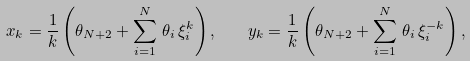Convert formula to latex. <formula><loc_0><loc_0><loc_500><loc_500>x _ { k } = \frac { 1 } { k } \left ( \theta _ { N + 2 } + \sum _ { i = 1 } ^ { N } \, \theta _ { i } \, \xi _ { i } ^ { k } \right ) , \quad y _ { k } = \frac { 1 } { k } \left ( \theta _ { N + 2 } + \sum _ { i = 1 } ^ { N } \, \theta _ { i } \, \xi _ { i } ^ { - k } \right ) ,</formula> 